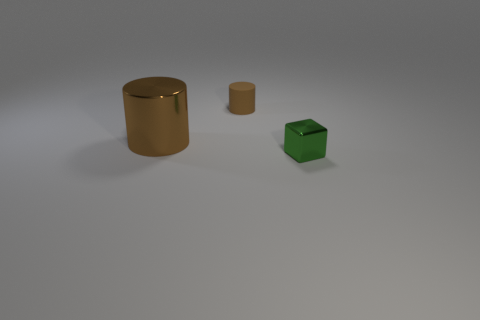There is another brown thing that is the same shape as the tiny brown thing; what material is it?
Give a very brief answer. Metal. Do the big thing and the small brown thing have the same material?
Your answer should be very brief. No. Is the number of tiny things behind the cube greater than the number of red cubes?
Offer a terse response. Yes. There is a brown cylinder in front of the brown cylinder that is right of the brown cylinder that is in front of the small brown matte object; what is its material?
Keep it short and to the point. Metal. What number of things are cyan objects or tiny things that are in front of the brown rubber cylinder?
Provide a short and direct response. 1. Is the color of the big cylinder that is in front of the tiny brown matte cylinder the same as the small rubber thing?
Your answer should be very brief. Yes. Are there more tiny green metal cubes in front of the rubber thing than brown objects in front of the big metallic thing?
Ensure brevity in your answer.  Yes. Are there any other things that are the same color as the metal block?
Give a very brief answer. No. How many things are brown rubber cylinders or big metal things?
Your response must be concise. 2. Is the size of the metallic thing that is behind the green metallic cube the same as the tiny green metallic block?
Your answer should be very brief. No. 